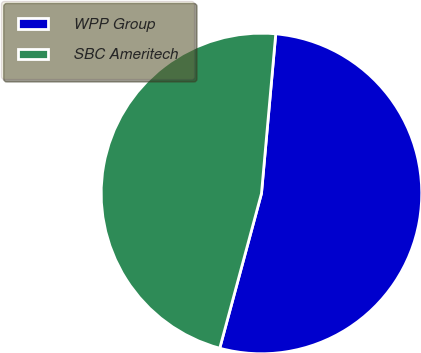<chart> <loc_0><loc_0><loc_500><loc_500><pie_chart><fcel>WPP Group<fcel>SBC Ameritech<nl><fcel>52.77%<fcel>47.23%<nl></chart> 